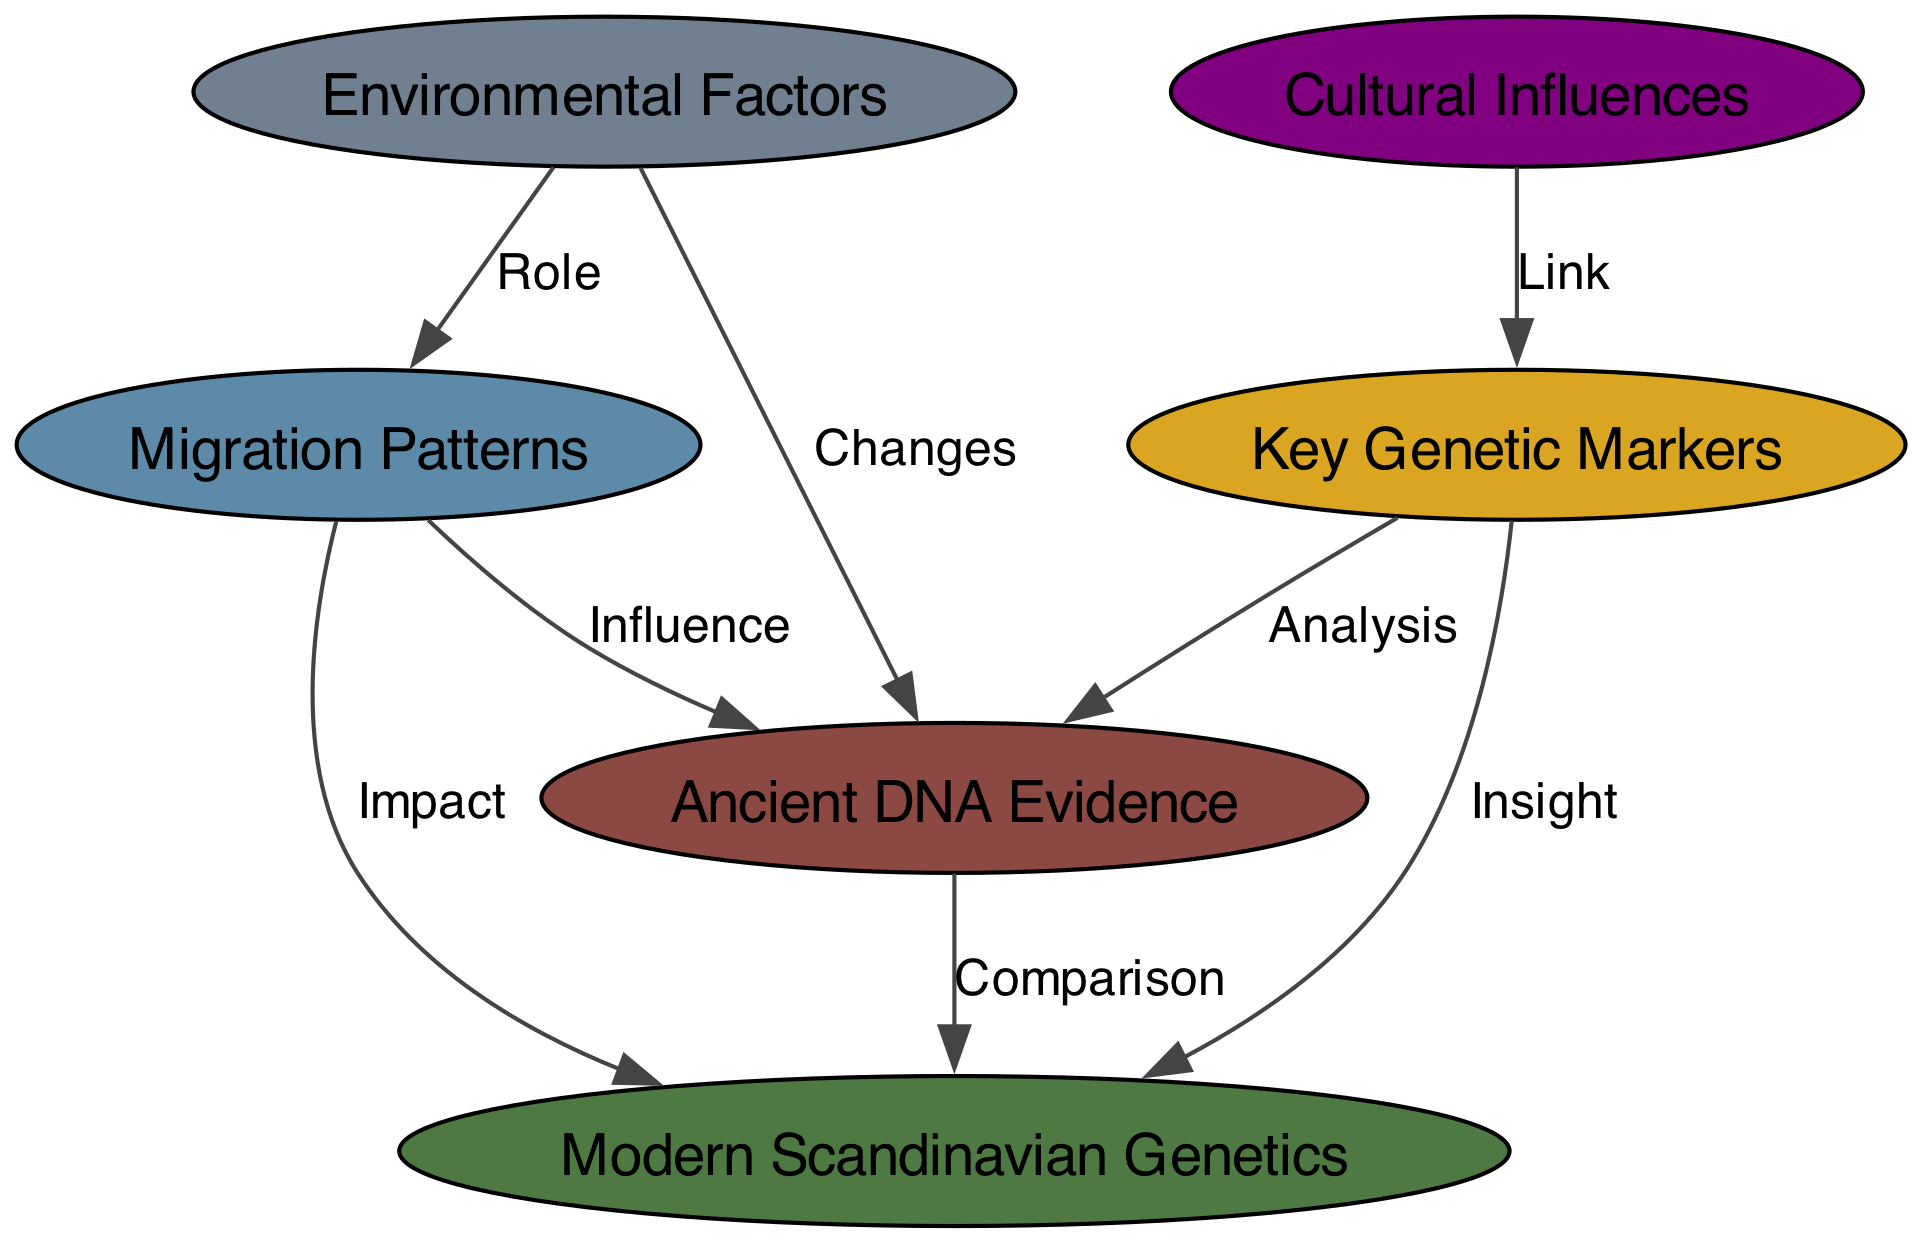What are the two primary categories of genetics depicted in the diagram? The diagram has two main nodes related to genetics: "Ancient DNA Evidence" and "Modern Scandinavian Genetics," which represent the genetic samples from ancient populations and contemporary Scandinavians respectively.
Answer: Ancient DNA Evidence, Modern Scandinavian Genetics How many nodes are present in the diagram? The diagram displays six nodes: "Ancient DNA Evidence," "Modern Scandinavian Genetics," "Migration Patterns," "Key Genetic Markers," "Cultural Influences," and "Environmental Factors."
Answer: Six What is the relationship between migration patterns and ancient evidence? The diagram indicates that migration patterns influence ancient evidence, as represented by the edge labeled "Influence" connecting the two nodes.
Answer: Influence Which node corresponds to the impact of climatic changes? The node titled "Environmental Factors" details the impact of climatic changes and geography on genetic evolution.
Answer: Environmental Factors How do cultural influences connect to genetic markers in the diagram? The diagram shows a link between cultural influences and genetic markers through the designated edge labeled "Link," illustrating that cultural aspects affect genetic lineage.
Answer: Link What is the described role of environmental factors in relation to migration patterns? The diagram states that environmental factors have a role in influencing migration patterns, as indicated by the edge labeled "Role" connecting these nodes.
Answer: Role What type of markers are analyzed from ancient evidence? The diagram specifies that "Key Genetic Markers," such as Y-chromosome haplogroups and mitochondrial DNA, are analyzed in relation to ancient evidence.
Answer: Key Genetic Markers What does the edge labeled "Comparison" illustrate? This edge labeled "Comparison" indicates the relationship of comparing ancient DNA evidence with modern Scandinavian genetics to understand genetic evolution over time.
Answer: Comparison How many edges are illustrated in the diagram? The diagram contains a total of eight edges connecting the nodes, showing various relationships among them.
Answer: Eight 